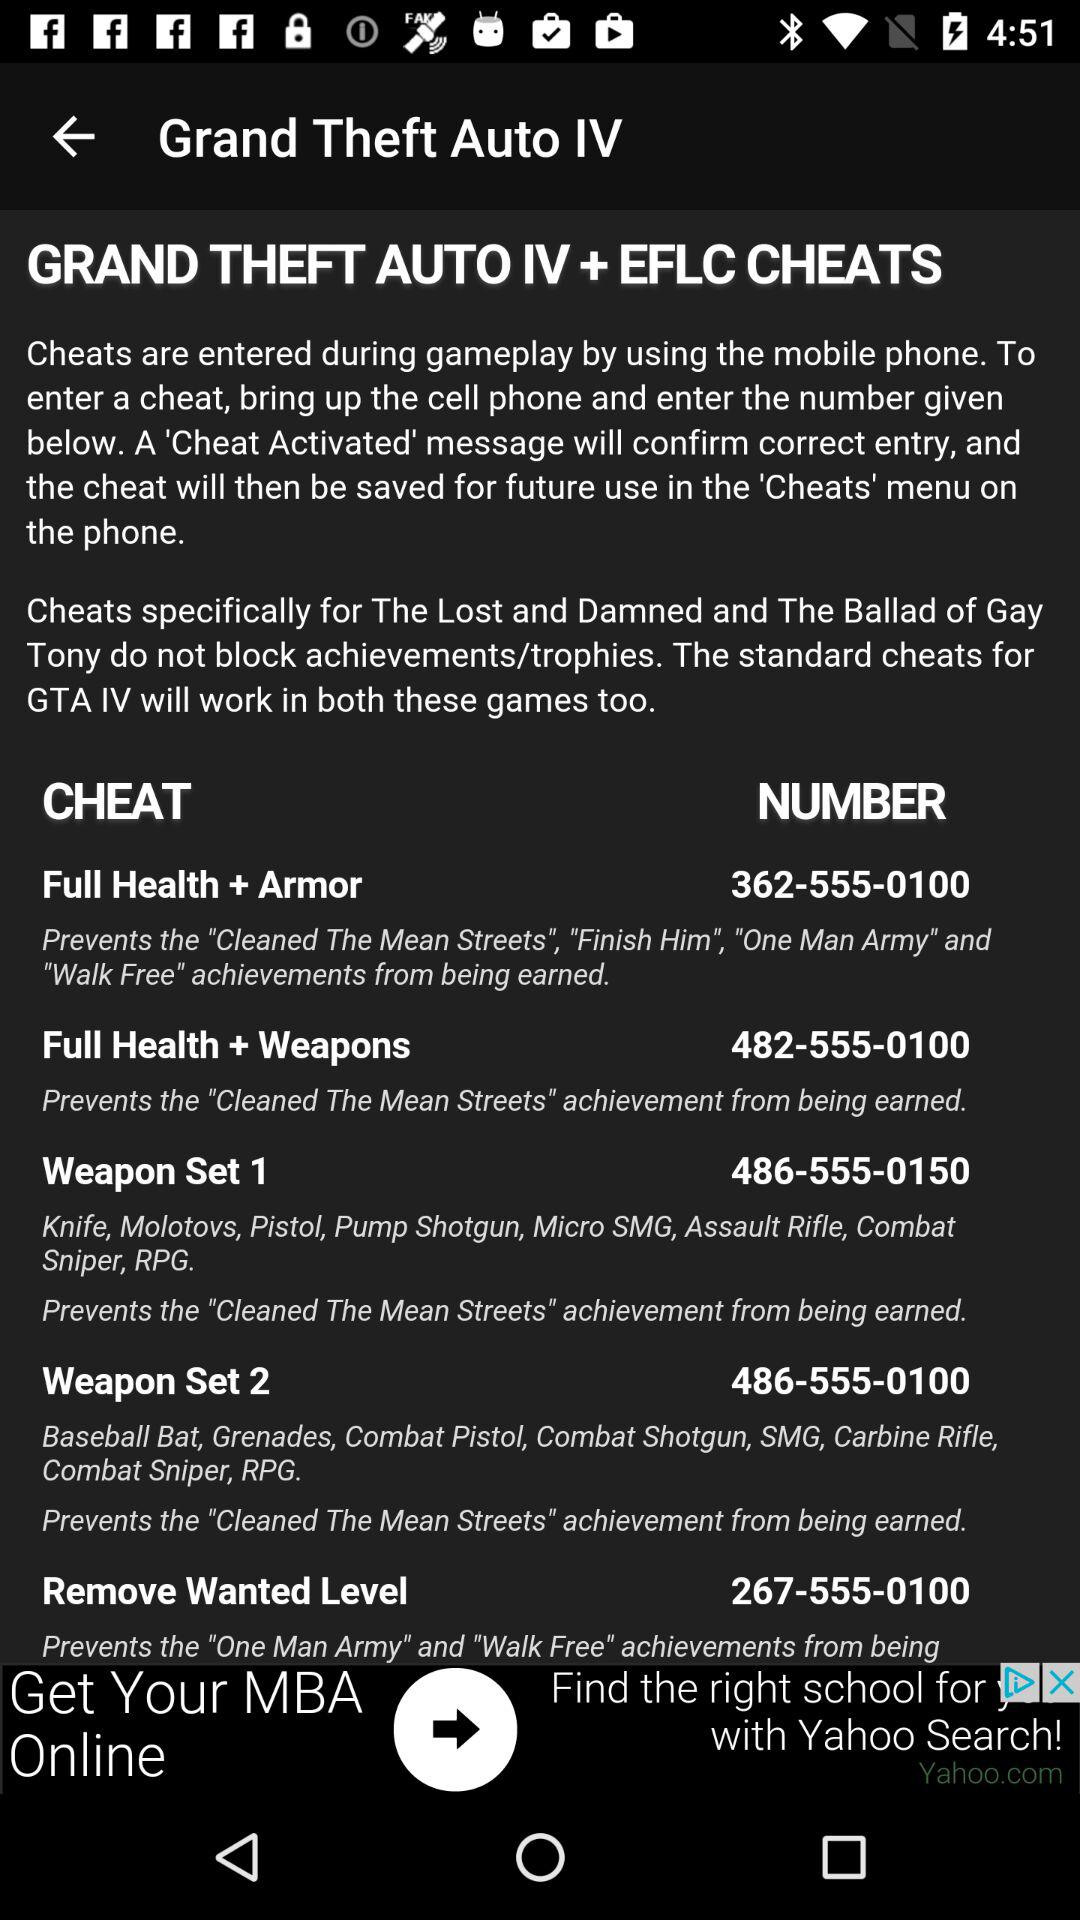What is the topic name given on the screen? The topic name that is given on the screen is "Grand Theft Auto IV". 